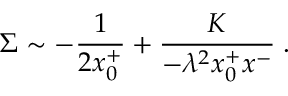Convert formula to latex. <formula><loc_0><loc_0><loc_500><loc_500>\Sigma \sim - { \frac { 1 } { 2 x _ { 0 } ^ { + } } } + \frac { K } { - \lambda ^ { 2 } x _ { 0 } ^ { + } x ^ { - } } \, .</formula> 